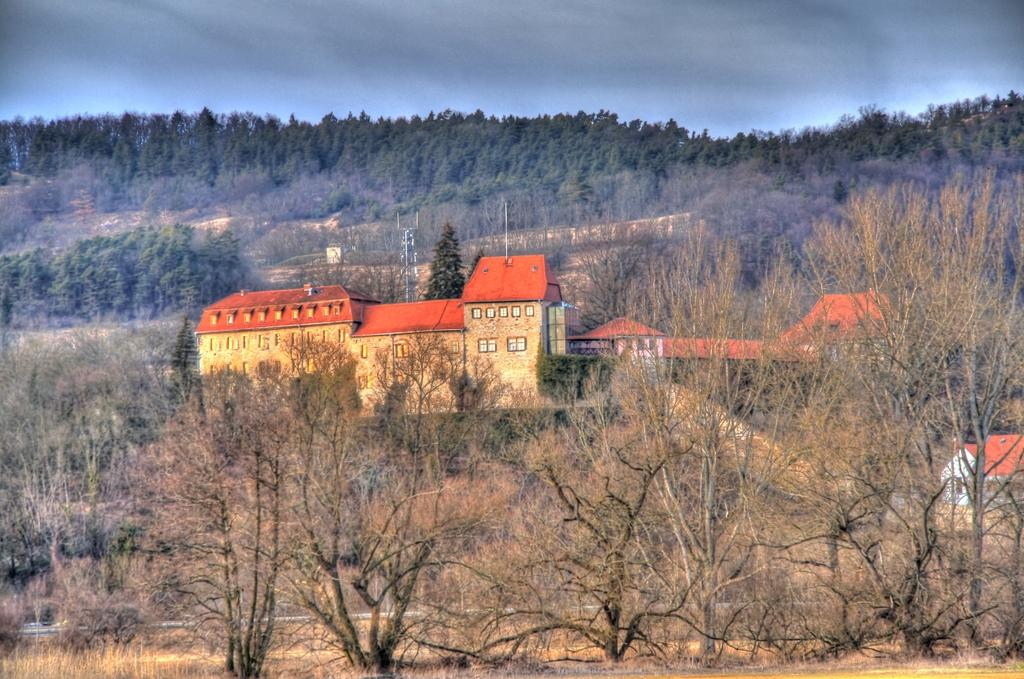What can be seen in the foreground of the image? There are trees, buildings, and a tower in the foreground of the image. What is visible at the top of the image? The sky is visible at the top of the image. Where is the map located in the image? There is no map present in the image. What type of basket is hanging from the tower in the image? There is no basket hanging from the tower in the image. 